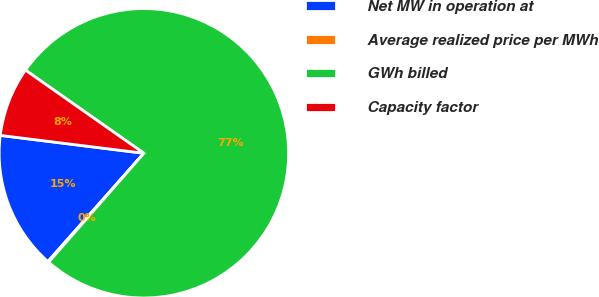Convert chart. <chart><loc_0><loc_0><loc_500><loc_500><pie_chart><fcel>Net MW in operation at<fcel>Average realized price per MWh<fcel>GWh billed<fcel>Capacity factor<nl><fcel>15.43%<fcel>0.11%<fcel>76.7%<fcel>7.77%<nl></chart> 